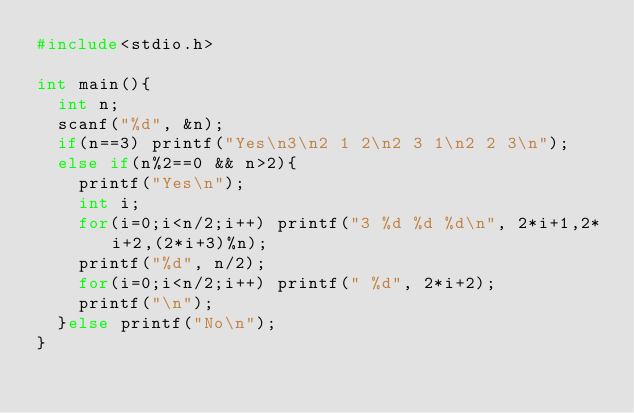<code> <loc_0><loc_0><loc_500><loc_500><_C_>#include<stdio.h>

int main(){
  int n;
  scanf("%d", &n);
  if(n==3) printf("Yes\n3\n2 1 2\n2 3 1\n2 2 3\n");
  else if(n%2==0 && n>2){
    printf("Yes\n");
    int i;
    for(i=0;i<n/2;i++) printf("3 %d %d %d\n", 2*i+1,2*i+2,(2*i+3)%n);
    printf("%d", n/2);
    for(i=0;i<n/2;i++) printf(" %d", 2*i+2);
    printf("\n");
  }else printf("No\n");
}</code> 